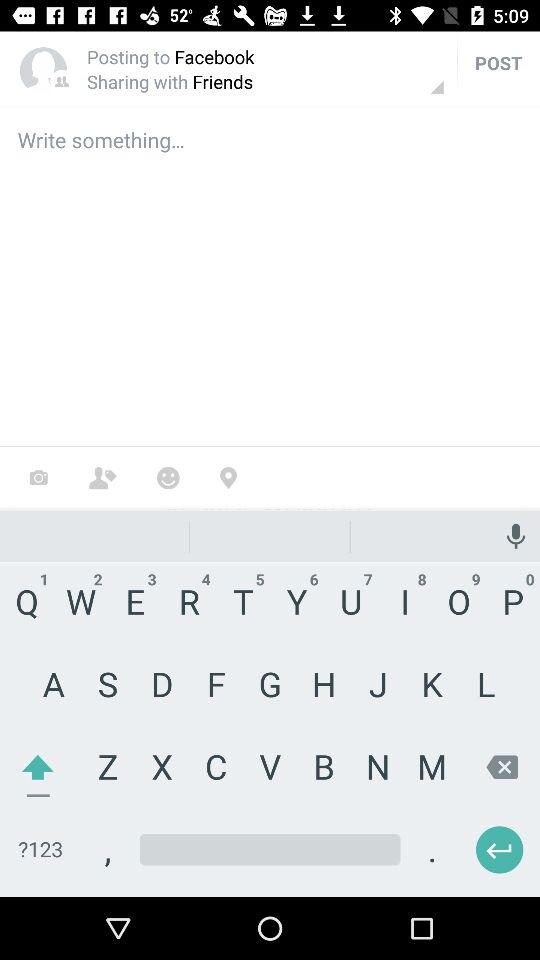What is the user name? The user name is Grace. 